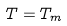Convert formula to latex. <formula><loc_0><loc_0><loc_500><loc_500>T = T _ { m }</formula> 